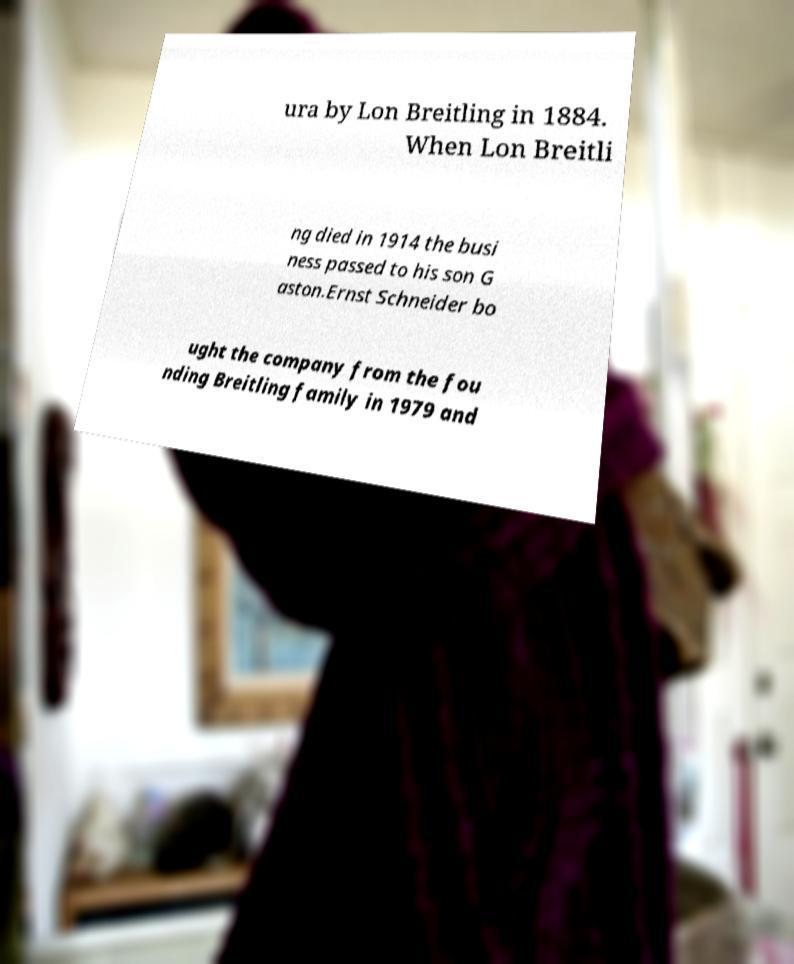Please read and relay the text visible in this image. What does it say? ura by Lon Breitling in 1884. When Lon Breitli ng died in 1914 the busi ness passed to his son G aston.Ernst Schneider bo ught the company from the fou nding Breitling family in 1979 and 